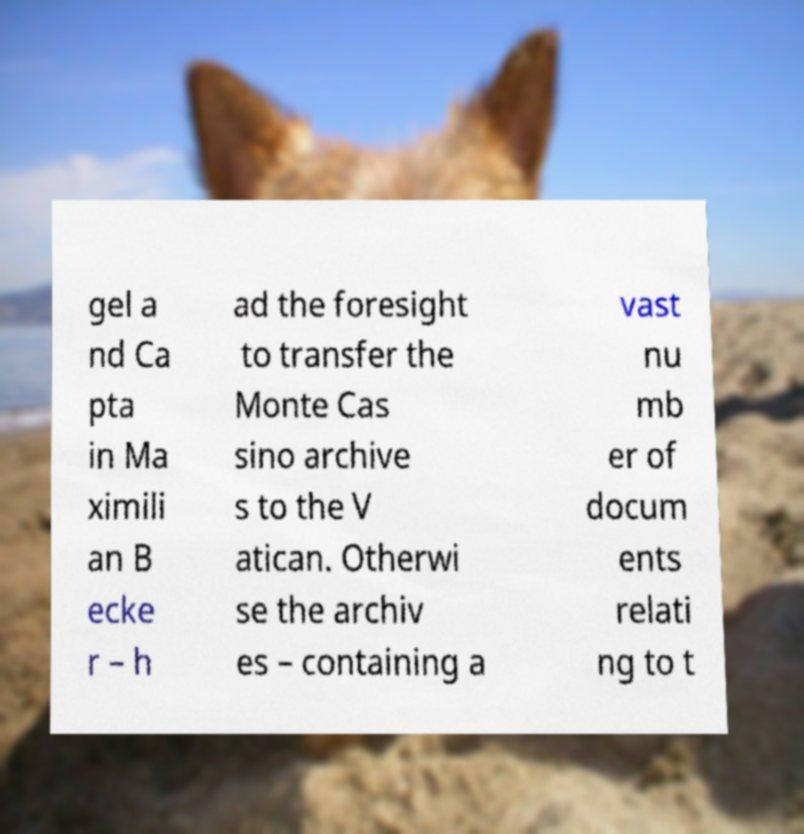For documentation purposes, I need the text within this image transcribed. Could you provide that? gel a nd Ca pta in Ma ximili an B ecke r – h ad the foresight to transfer the Monte Cas sino archive s to the V atican. Otherwi se the archiv es – containing a vast nu mb er of docum ents relati ng to t 